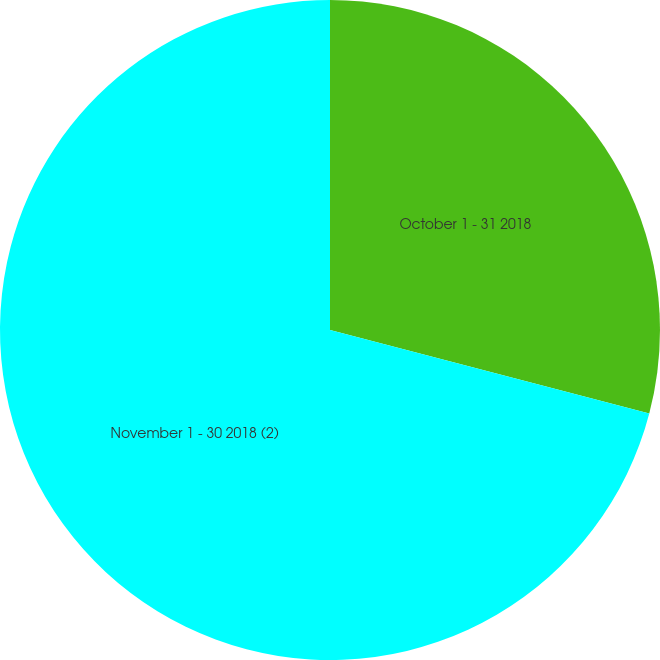Convert chart to OTSL. <chart><loc_0><loc_0><loc_500><loc_500><pie_chart><fcel>October 1 - 31 2018<fcel>November 1 - 30 2018 (2)<nl><fcel>29.07%<fcel>70.93%<nl></chart> 